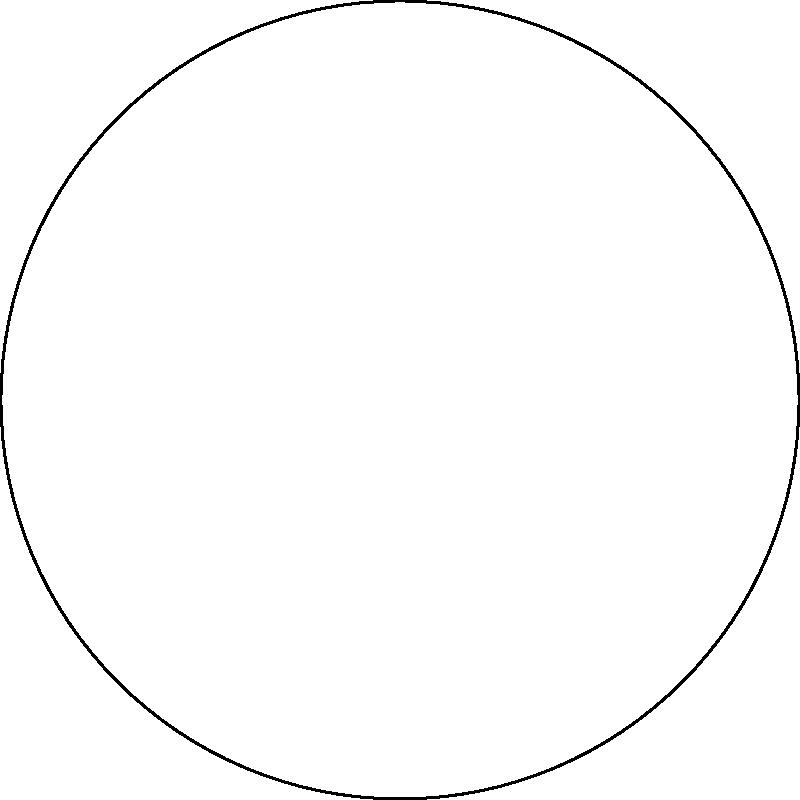In the context of creating optical illusions using hyperbolic geometry in graphic design, how does the Poincaré disk model contribute to generating non-Euclidean visual effects, and what principle allows for the representation of infinite hyperbolic space within a finite circle? To understand how the Poincaré disk model contributes to creating optical illusions using hyperbolic geometry in graphic design, let's break it down step-by-step:

1. The Poincaré disk model is a representation of hyperbolic geometry within a circular disk.

2. In this model, the entire infinite hyperbolic plane is mapped to the interior of a circle.

3. Points in the hyperbolic plane are represented as points within the disk.

4. Hyperbolic lines are represented as circular arcs that intersect the boundary circle at right angles.

5. The key principle that allows for the representation of infinite hyperbolic space within a finite circle is conformal mapping.

6. Conformal mapping preserves angles but distorts distances, especially near the boundary of the disk.

7. As objects approach the boundary of the disk, they appear to shrink infinitely, creating an illusion of infinite space.

8. This property can be exploited in graphic design to create optical illusions of infinite patterns or impossible geometric constructions.

9. For example, M.C. Escher's "Circle Limit" series uses this principle to create tessellations that seem to extend infinitely within a circular boundary.

10. In graphic design, this model can be used to create:
    a) Infinite recursive patterns
    b) Impossible geometric figures
    c) Illusions of depth and space within a finite area

11. The distortion of space near the boundary of the disk can be used to create dramatic perspective effects or to emphasize certain elements of a design.

12. By manipulating the scale and position of elements within the Poincaré disk, designers can create visually striking compositions that challenge viewers' perceptions of space and geometry.

The principle that allows for this representation is the conformal nature of the Poincaré disk model, which preserves angles but distorts distances, especially near the boundary of the disk.
Answer: Conformal mapping, preserving angles but distorting distances 